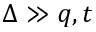<formula> <loc_0><loc_0><loc_500><loc_500>\Delta \gg q , t</formula> 